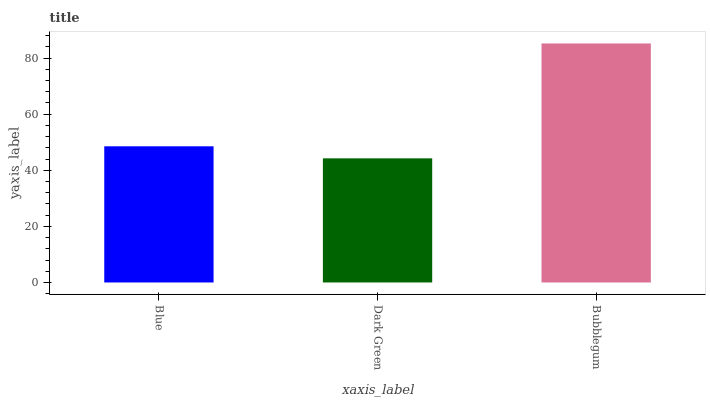Is Dark Green the minimum?
Answer yes or no. Yes. Is Bubblegum the maximum?
Answer yes or no. Yes. Is Bubblegum the minimum?
Answer yes or no. No. Is Dark Green the maximum?
Answer yes or no. No. Is Bubblegum greater than Dark Green?
Answer yes or no. Yes. Is Dark Green less than Bubblegum?
Answer yes or no. Yes. Is Dark Green greater than Bubblegum?
Answer yes or no. No. Is Bubblegum less than Dark Green?
Answer yes or no. No. Is Blue the high median?
Answer yes or no. Yes. Is Blue the low median?
Answer yes or no. Yes. Is Bubblegum the high median?
Answer yes or no. No. Is Dark Green the low median?
Answer yes or no. No. 